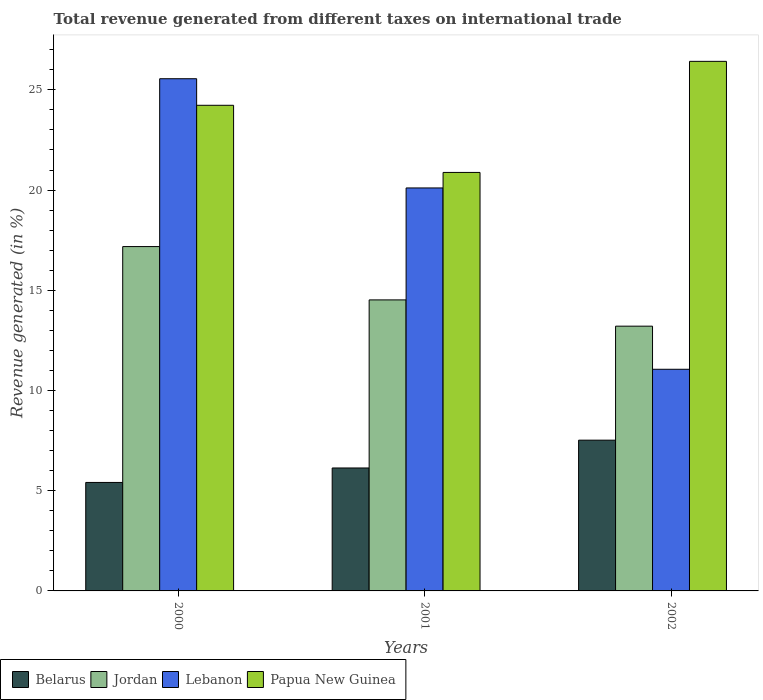How many different coloured bars are there?
Offer a very short reply. 4. How many groups of bars are there?
Your response must be concise. 3. Are the number of bars per tick equal to the number of legend labels?
Ensure brevity in your answer.  Yes. How many bars are there on the 1st tick from the left?
Ensure brevity in your answer.  4. How many bars are there on the 2nd tick from the right?
Offer a terse response. 4. What is the label of the 1st group of bars from the left?
Your response must be concise. 2000. What is the total revenue generated in Papua New Guinea in 2000?
Provide a short and direct response. 24.23. Across all years, what is the maximum total revenue generated in Papua New Guinea?
Provide a succinct answer. 26.42. Across all years, what is the minimum total revenue generated in Lebanon?
Make the answer very short. 11.06. In which year was the total revenue generated in Jordan minimum?
Make the answer very short. 2002. What is the total total revenue generated in Belarus in the graph?
Provide a succinct answer. 19.07. What is the difference between the total revenue generated in Belarus in 2000 and that in 2002?
Provide a succinct answer. -2.11. What is the difference between the total revenue generated in Papua New Guinea in 2000 and the total revenue generated in Jordan in 2002?
Provide a short and direct response. 11.02. What is the average total revenue generated in Jordan per year?
Your response must be concise. 14.97. In the year 2001, what is the difference between the total revenue generated in Lebanon and total revenue generated in Jordan?
Provide a succinct answer. 5.59. In how many years, is the total revenue generated in Jordan greater than 22 %?
Offer a very short reply. 0. What is the ratio of the total revenue generated in Belarus in 2000 to that in 2001?
Offer a very short reply. 0.88. Is the difference between the total revenue generated in Lebanon in 2000 and 2002 greater than the difference between the total revenue generated in Jordan in 2000 and 2002?
Your answer should be very brief. Yes. What is the difference between the highest and the second highest total revenue generated in Belarus?
Your response must be concise. 1.39. What is the difference between the highest and the lowest total revenue generated in Jordan?
Your answer should be compact. 3.97. Is the sum of the total revenue generated in Lebanon in 2000 and 2002 greater than the maximum total revenue generated in Belarus across all years?
Make the answer very short. Yes. Is it the case that in every year, the sum of the total revenue generated in Papua New Guinea and total revenue generated in Belarus is greater than the sum of total revenue generated in Jordan and total revenue generated in Lebanon?
Give a very brief answer. No. What does the 2nd bar from the left in 2000 represents?
Your answer should be very brief. Jordan. What does the 3rd bar from the right in 2000 represents?
Keep it short and to the point. Jordan. Is it the case that in every year, the sum of the total revenue generated in Papua New Guinea and total revenue generated in Belarus is greater than the total revenue generated in Jordan?
Your answer should be compact. Yes. Are all the bars in the graph horizontal?
Your answer should be very brief. No. Are the values on the major ticks of Y-axis written in scientific E-notation?
Your response must be concise. No. How many legend labels are there?
Your answer should be very brief. 4. How are the legend labels stacked?
Ensure brevity in your answer.  Horizontal. What is the title of the graph?
Keep it short and to the point. Total revenue generated from different taxes on international trade. Does "Channel Islands" appear as one of the legend labels in the graph?
Provide a short and direct response. No. What is the label or title of the X-axis?
Make the answer very short. Years. What is the label or title of the Y-axis?
Provide a short and direct response. Revenue generated (in %). What is the Revenue generated (in %) in Belarus in 2000?
Your response must be concise. 5.41. What is the Revenue generated (in %) in Jordan in 2000?
Offer a very short reply. 17.18. What is the Revenue generated (in %) of Lebanon in 2000?
Make the answer very short. 25.56. What is the Revenue generated (in %) of Papua New Guinea in 2000?
Your answer should be very brief. 24.23. What is the Revenue generated (in %) in Belarus in 2001?
Offer a very short reply. 6.13. What is the Revenue generated (in %) of Jordan in 2001?
Your answer should be very brief. 14.52. What is the Revenue generated (in %) of Lebanon in 2001?
Offer a very short reply. 20.11. What is the Revenue generated (in %) in Papua New Guinea in 2001?
Your answer should be compact. 20.88. What is the Revenue generated (in %) of Belarus in 2002?
Give a very brief answer. 7.52. What is the Revenue generated (in %) of Jordan in 2002?
Make the answer very short. 13.21. What is the Revenue generated (in %) of Lebanon in 2002?
Offer a terse response. 11.06. What is the Revenue generated (in %) in Papua New Guinea in 2002?
Offer a terse response. 26.42. Across all years, what is the maximum Revenue generated (in %) in Belarus?
Offer a terse response. 7.52. Across all years, what is the maximum Revenue generated (in %) in Jordan?
Ensure brevity in your answer.  17.18. Across all years, what is the maximum Revenue generated (in %) of Lebanon?
Make the answer very short. 25.56. Across all years, what is the maximum Revenue generated (in %) of Papua New Guinea?
Offer a very short reply. 26.42. Across all years, what is the minimum Revenue generated (in %) of Belarus?
Provide a short and direct response. 5.41. Across all years, what is the minimum Revenue generated (in %) in Jordan?
Your answer should be very brief. 13.21. Across all years, what is the minimum Revenue generated (in %) in Lebanon?
Your answer should be compact. 11.06. Across all years, what is the minimum Revenue generated (in %) of Papua New Guinea?
Your answer should be very brief. 20.88. What is the total Revenue generated (in %) in Belarus in the graph?
Make the answer very short. 19.07. What is the total Revenue generated (in %) in Jordan in the graph?
Provide a succinct answer. 44.91. What is the total Revenue generated (in %) of Lebanon in the graph?
Make the answer very short. 56.72. What is the total Revenue generated (in %) of Papua New Guinea in the graph?
Provide a succinct answer. 71.53. What is the difference between the Revenue generated (in %) in Belarus in 2000 and that in 2001?
Your response must be concise. -0.72. What is the difference between the Revenue generated (in %) of Jordan in 2000 and that in 2001?
Offer a terse response. 2.66. What is the difference between the Revenue generated (in %) of Lebanon in 2000 and that in 2001?
Offer a very short reply. 5.45. What is the difference between the Revenue generated (in %) of Papua New Guinea in 2000 and that in 2001?
Offer a terse response. 3.35. What is the difference between the Revenue generated (in %) of Belarus in 2000 and that in 2002?
Your answer should be compact. -2.11. What is the difference between the Revenue generated (in %) in Jordan in 2000 and that in 2002?
Ensure brevity in your answer.  3.97. What is the difference between the Revenue generated (in %) of Lebanon in 2000 and that in 2002?
Provide a short and direct response. 14.5. What is the difference between the Revenue generated (in %) in Papua New Guinea in 2000 and that in 2002?
Your answer should be very brief. -2.19. What is the difference between the Revenue generated (in %) in Belarus in 2001 and that in 2002?
Offer a terse response. -1.39. What is the difference between the Revenue generated (in %) of Jordan in 2001 and that in 2002?
Ensure brevity in your answer.  1.31. What is the difference between the Revenue generated (in %) of Lebanon in 2001 and that in 2002?
Provide a succinct answer. 9.05. What is the difference between the Revenue generated (in %) in Papua New Guinea in 2001 and that in 2002?
Offer a very short reply. -5.54. What is the difference between the Revenue generated (in %) of Belarus in 2000 and the Revenue generated (in %) of Jordan in 2001?
Give a very brief answer. -9.11. What is the difference between the Revenue generated (in %) of Belarus in 2000 and the Revenue generated (in %) of Lebanon in 2001?
Your response must be concise. -14.69. What is the difference between the Revenue generated (in %) in Belarus in 2000 and the Revenue generated (in %) in Papua New Guinea in 2001?
Provide a short and direct response. -15.47. What is the difference between the Revenue generated (in %) of Jordan in 2000 and the Revenue generated (in %) of Lebanon in 2001?
Give a very brief answer. -2.93. What is the difference between the Revenue generated (in %) of Jordan in 2000 and the Revenue generated (in %) of Papua New Guinea in 2001?
Your answer should be compact. -3.7. What is the difference between the Revenue generated (in %) in Lebanon in 2000 and the Revenue generated (in %) in Papua New Guinea in 2001?
Make the answer very short. 4.68. What is the difference between the Revenue generated (in %) of Belarus in 2000 and the Revenue generated (in %) of Jordan in 2002?
Offer a terse response. -7.8. What is the difference between the Revenue generated (in %) in Belarus in 2000 and the Revenue generated (in %) in Lebanon in 2002?
Provide a short and direct response. -5.65. What is the difference between the Revenue generated (in %) of Belarus in 2000 and the Revenue generated (in %) of Papua New Guinea in 2002?
Your response must be concise. -21.01. What is the difference between the Revenue generated (in %) in Jordan in 2000 and the Revenue generated (in %) in Lebanon in 2002?
Give a very brief answer. 6.12. What is the difference between the Revenue generated (in %) in Jordan in 2000 and the Revenue generated (in %) in Papua New Guinea in 2002?
Your answer should be compact. -9.24. What is the difference between the Revenue generated (in %) of Lebanon in 2000 and the Revenue generated (in %) of Papua New Guinea in 2002?
Provide a succinct answer. -0.87. What is the difference between the Revenue generated (in %) in Belarus in 2001 and the Revenue generated (in %) in Jordan in 2002?
Make the answer very short. -7.08. What is the difference between the Revenue generated (in %) in Belarus in 2001 and the Revenue generated (in %) in Lebanon in 2002?
Offer a very short reply. -4.92. What is the difference between the Revenue generated (in %) of Belarus in 2001 and the Revenue generated (in %) of Papua New Guinea in 2002?
Provide a short and direct response. -20.29. What is the difference between the Revenue generated (in %) of Jordan in 2001 and the Revenue generated (in %) of Lebanon in 2002?
Provide a short and direct response. 3.46. What is the difference between the Revenue generated (in %) in Jordan in 2001 and the Revenue generated (in %) in Papua New Guinea in 2002?
Provide a succinct answer. -11.9. What is the difference between the Revenue generated (in %) in Lebanon in 2001 and the Revenue generated (in %) in Papua New Guinea in 2002?
Your answer should be very brief. -6.32. What is the average Revenue generated (in %) of Belarus per year?
Provide a short and direct response. 6.36. What is the average Revenue generated (in %) of Jordan per year?
Your response must be concise. 14.97. What is the average Revenue generated (in %) in Lebanon per year?
Your response must be concise. 18.91. What is the average Revenue generated (in %) in Papua New Guinea per year?
Ensure brevity in your answer.  23.84. In the year 2000, what is the difference between the Revenue generated (in %) of Belarus and Revenue generated (in %) of Jordan?
Ensure brevity in your answer.  -11.77. In the year 2000, what is the difference between the Revenue generated (in %) of Belarus and Revenue generated (in %) of Lebanon?
Your response must be concise. -20.14. In the year 2000, what is the difference between the Revenue generated (in %) in Belarus and Revenue generated (in %) in Papua New Guinea?
Your answer should be compact. -18.82. In the year 2000, what is the difference between the Revenue generated (in %) of Jordan and Revenue generated (in %) of Lebanon?
Make the answer very short. -8.37. In the year 2000, what is the difference between the Revenue generated (in %) in Jordan and Revenue generated (in %) in Papua New Guinea?
Provide a short and direct response. -7.05. In the year 2000, what is the difference between the Revenue generated (in %) of Lebanon and Revenue generated (in %) of Papua New Guinea?
Offer a terse response. 1.33. In the year 2001, what is the difference between the Revenue generated (in %) of Belarus and Revenue generated (in %) of Jordan?
Make the answer very short. -8.39. In the year 2001, what is the difference between the Revenue generated (in %) of Belarus and Revenue generated (in %) of Lebanon?
Provide a short and direct response. -13.97. In the year 2001, what is the difference between the Revenue generated (in %) in Belarus and Revenue generated (in %) in Papua New Guinea?
Your answer should be very brief. -14.75. In the year 2001, what is the difference between the Revenue generated (in %) of Jordan and Revenue generated (in %) of Lebanon?
Provide a short and direct response. -5.59. In the year 2001, what is the difference between the Revenue generated (in %) of Jordan and Revenue generated (in %) of Papua New Guinea?
Ensure brevity in your answer.  -6.36. In the year 2001, what is the difference between the Revenue generated (in %) of Lebanon and Revenue generated (in %) of Papua New Guinea?
Offer a terse response. -0.77. In the year 2002, what is the difference between the Revenue generated (in %) in Belarus and Revenue generated (in %) in Jordan?
Keep it short and to the point. -5.69. In the year 2002, what is the difference between the Revenue generated (in %) in Belarus and Revenue generated (in %) in Lebanon?
Offer a terse response. -3.54. In the year 2002, what is the difference between the Revenue generated (in %) in Belarus and Revenue generated (in %) in Papua New Guinea?
Offer a very short reply. -18.9. In the year 2002, what is the difference between the Revenue generated (in %) in Jordan and Revenue generated (in %) in Lebanon?
Offer a very short reply. 2.15. In the year 2002, what is the difference between the Revenue generated (in %) in Jordan and Revenue generated (in %) in Papua New Guinea?
Keep it short and to the point. -13.21. In the year 2002, what is the difference between the Revenue generated (in %) of Lebanon and Revenue generated (in %) of Papua New Guinea?
Your answer should be very brief. -15.36. What is the ratio of the Revenue generated (in %) in Belarus in 2000 to that in 2001?
Provide a succinct answer. 0.88. What is the ratio of the Revenue generated (in %) in Jordan in 2000 to that in 2001?
Give a very brief answer. 1.18. What is the ratio of the Revenue generated (in %) in Lebanon in 2000 to that in 2001?
Offer a very short reply. 1.27. What is the ratio of the Revenue generated (in %) in Papua New Guinea in 2000 to that in 2001?
Offer a very short reply. 1.16. What is the ratio of the Revenue generated (in %) of Belarus in 2000 to that in 2002?
Ensure brevity in your answer.  0.72. What is the ratio of the Revenue generated (in %) of Jordan in 2000 to that in 2002?
Provide a succinct answer. 1.3. What is the ratio of the Revenue generated (in %) in Lebanon in 2000 to that in 2002?
Make the answer very short. 2.31. What is the ratio of the Revenue generated (in %) in Papua New Guinea in 2000 to that in 2002?
Your answer should be compact. 0.92. What is the ratio of the Revenue generated (in %) of Belarus in 2001 to that in 2002?
Offer a terse response. 0.82. What is the ratio of the Revenue generated (in %) in Jordan in 2001 to that in 2002?
Ensure brevity in your answer.  1.1. What is the ratio of the Revenue generated (in %) of Lebanon in 2001 to that in 2002?
Your answer should be very brief. 1.82. What is the ratio of the Revenue generated (in %) of Papua New Guinea in 2001 to that in 2002?
Provide a short and direct response. 0.79. What is the difference between the highest and the second highest Revenue generated (in %) of Belarus?
Provide a short and direct response. 1.39. What is the difference between the highest and the second highest Revenue generated (in %) of Jordan?
Provide a short and direct response. 2.66. What is the difference between the highest and the second highest Revenue generated (in %) of Lebanon?
Make the answer very short. 5.45. What is the difference between the highest and the second highest Revenue generated (in %) of Papua New Guinea?
Your answer should be compact. 2.19. What is the difference between the highest and the lowest Revenue generated (in %) of Belarus?
Offer a very short reply. 2.11. What is the difference between the highest and the lowest Revenue generated (in %) of Jordan?
Provide a succinct answer. 3.97. What is the difference between the highest and the lowest Revenue generated (in %) in Lebanon?
Offer a very short reply. 14.5. What is the difference between the highest and the lowest Revenue generated (in %) of Papua New Guinea?
Provide a short and direct response. 5.54. 